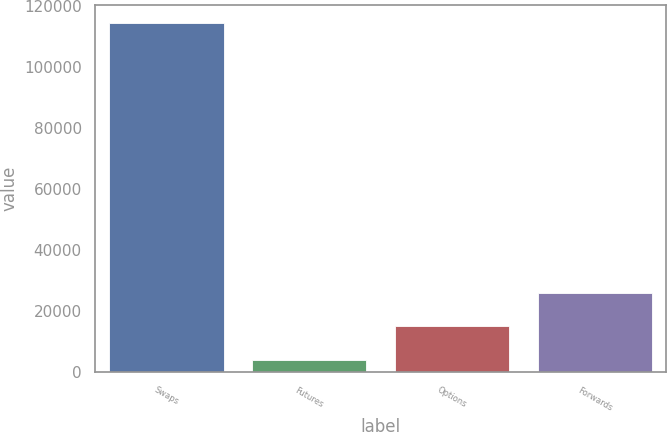Convert chart. <chart><loc_0><loc_0><loc_500><loc_500><bar_chart><fcel>Swaps<fcel>Futures<fcel>Options<fcel>Forwards<nl><fcel>114601<fcel>3987<fcel>15048.4<fcel>26109.8<nl></chart> 